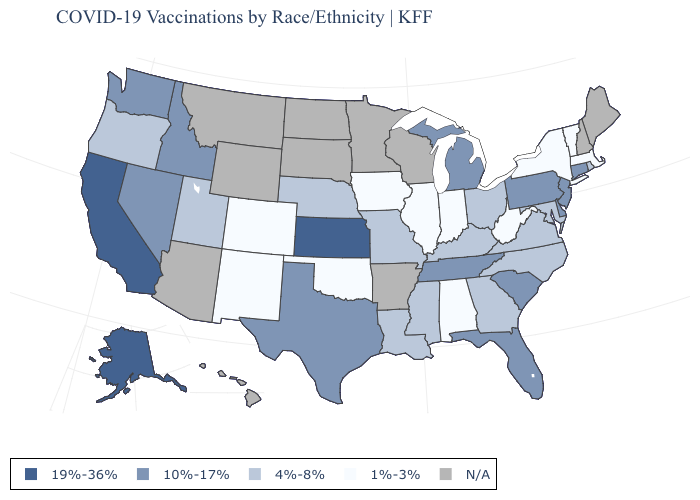Name the states that have a value in the range N/A?
Quick response, please. Arizona, Arkansas, Hawaii, Maine, Minnesota, Montana, New Hampshire, North Dakota, South Dakota, Wisconsin, Wyoming. What is the value of Utah?
Short answer required. 4%-8%. Does Alaska have the highest value in the West?
Answer briefly. Yes. Does Colorado have the lowest value in the USA?
Quick response, please. Yes. Does the first symbol in the legend represent the smallest category?
Short answer required. No. How many symbols are there in the legend?
Give a very brief answer. 5. Name the states that have a value in the range 19%-36%?
Write a very short answer. Alaska, California, Kansas. What is the value of Hawaii?
Short answer required. N/A. Name the states that have a value in the range 1%-3%?
Concise answer only. Alabama, Colorado, Illinois, Indiana, Iowa, Massachusetts, New Mexico, New York, Oklahoma, Vermont, West Virginia. Among the states that border Delaware , does Maryland have the highest value?
Be succinct. No. Which states have the lowest value in the MidWest?
Write a very short answer. Illinois, Indiana, Iowa. Does the first symbol in the legend represent the smallest category?
Answer briefly. No. Among the states that border California , does Nevada have the highest value?
Write a very short answer. Yes. What is the highest value in states that border Michigan?
Give a very brief answer. 4%-8%. 